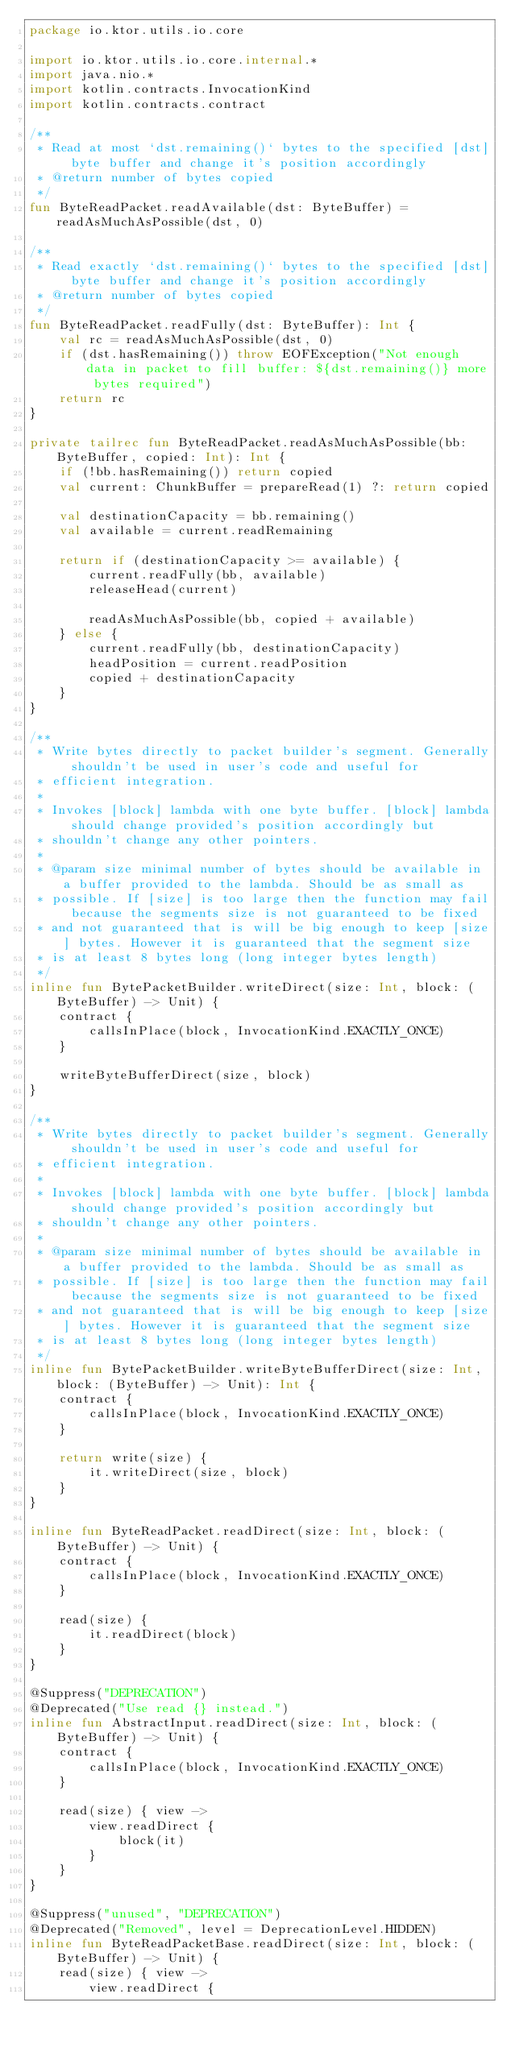<code> <loc_0><loc_0><loc_500><loc_500><_Kotlin_>package io.ktor.utils.io.core

import io.ktor.utils.io.core.internal.*
import java.nio.*
import kotlin.contracts.InvocationKind
import kotlin.contracts.contract

/**
 * Read at most `dst.remaining()` bytes to the specified [dst] byte buffer and change it's position accordingly
 * @return number of bytes copied
 */
fun ByteReadPacket.readAvailable(dst: ByteBuffer) = readAsMuchAsPossible(dst, 0)

/**
 * Read exactly `dst.remaining()` bytes to the specified [dst] byte buffer and change it's position accordingly
 * @return number of bytes copied
 */
fun ByteReadPacket.readFully(dst: ByteBuffer): Int {
    val rc = readAsMuchAsPossible(dst, 0)
    if (dst.hasRemaining()) throw EOFException("Not enough data in packet to fill buffer: ${dst.remaining()} more bytes required")
    return rc
}

private tailrec fun ByteReadPacket.readAsMuchAsPossible(bb: ByteBuffer, copied: Int): Int {
    if (!bb.hasRemaining()) return copied
    val current: ChunkBuffer = prepareRead(1) ?: return copied

    val destinationCapacity = bb.remaining()
    val available = current.readRemaining

    return if (destinationCapacity >= available) {
        current.readFully(bb, available)
        releaseHead(current)

        readAsMuchAsPossible(bb, copied + available)
    } else {
        current.readFully(bb, destinationCapacity)
        headPosition = current.readPosition
        copied + destinationCapacity
    }
}

/**
 * Write bytes directly to packet builder's segment. Generally shouldn't be used in user's code and useful for
 * efficient integration.
 *
 * Invokes [block] lambda with one byte buffer. [block] lambda should change provided's position accordingly but
 * shouldn't change any other pointers.
 *
 * @param size minimal number of bytes should be available in a buffer provided to the lambda. Should be as small as
 * possible. If [size] is too large then the function may fail because the segments size is not guaranteed to be fixed
 * and not guaranteed that is will be big enough to keep [size] bytes. However it is guaranteed that the segment size
 * is at least 8 bytes long (long integer bytes length)
 */
inline fun BytePacketBuilder.writeDirect(size: Int, block: (ByteBuffer) -> Unit) {
    contract {
        callsInPlace(block, InvocationKind.EXACTLY_ONCE)
    }

    writeByteBufferDirect(size, block)
}

/**
 * Write bytes directly to packet builder's segment. Generally shouldn't be used in user's code and useful for
 * efficient integration.
 *
 * Invokes [block] lambda with one byte buffer. [block] lambda should change provided's position accordingly but
 * shouldn't change any other pointers.
 *
 * @param size minimal number of bytes should be available in a buffer provided to the lambda. Should be as small as
 * possible. If [size] is too large then the function may fail because the segments size is not guaranteed to be fixed
 * and not guaranteed that is will be big enough to keep [size] bytes. However it is guaranteed that the segment size
 * is at least 8 bytes long (long integer bytes length)
 */
inline fun BytePacketBuilder.writeByteBufferDirect(size: Int, block: (ByteBuffer) -> Unit): Int {
    contract {
        callsInPlace(block, InvocationKind.EXACTLY_ONCE)
    }

    return write(size) {
        it.writeDirect(size, block)
    }
}

inline fun ByteReadPacket.readDirect(size: Int, block: (ByteBuffer) -> Unit) {
    contract {
        callsInPlace(block, InvocationKind.EXACTLY_ONCE)
    }

    read(size) {
        it.readDirect(block)
    }
}

@Suppress("DEPRECATION")
@Deprecated("Use read {} instead.")
inline fun AbstractInput.readDirect(size: Int, block: (ByteBuffer) -> Unit) {
    contract {
        callsInPlace(block, InvocationKind.EXACTLY_ONCE)
    }

    read(size) { view ->
        view.readDirect {
            block(it)
        }
    }
}

@Suppress("unused", "DEPRECATION")
@Deprecated("Removed", level = DeprecationLevel.HIDDEN)
inline fun ByteReadPacketBase.readDirect(size: Int, block: (ByteBuffer) -> Unit) {
    read(size) { view ->
        view.readDirect {</code> 